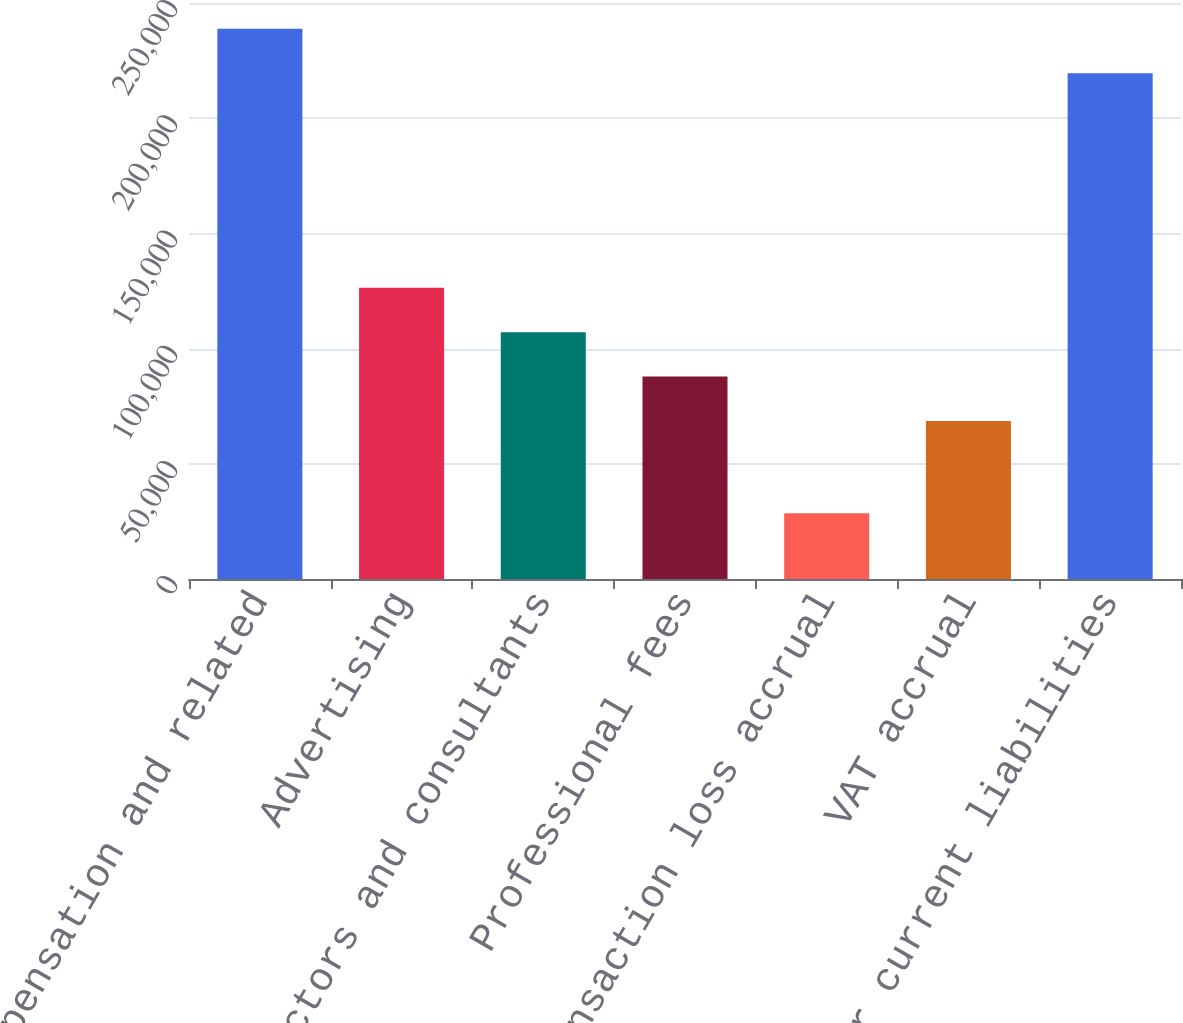Convert chart. <chart><loc_0><loc_0><loc_500><loc_500><bar_chart><fcel>Compensation and related<fcel>Advertising<fcel>Contractors and consultants<fcel>Professional fees<fcel>Transaction loss accrual<fcel>VAT accrual<fcel>Other current liabilities<nl><fcel>238854<fcel>126444<fcel>107144<fcel>87842.8<fcel>28506<fcel>68542<fcel>219553<nl></chart> 